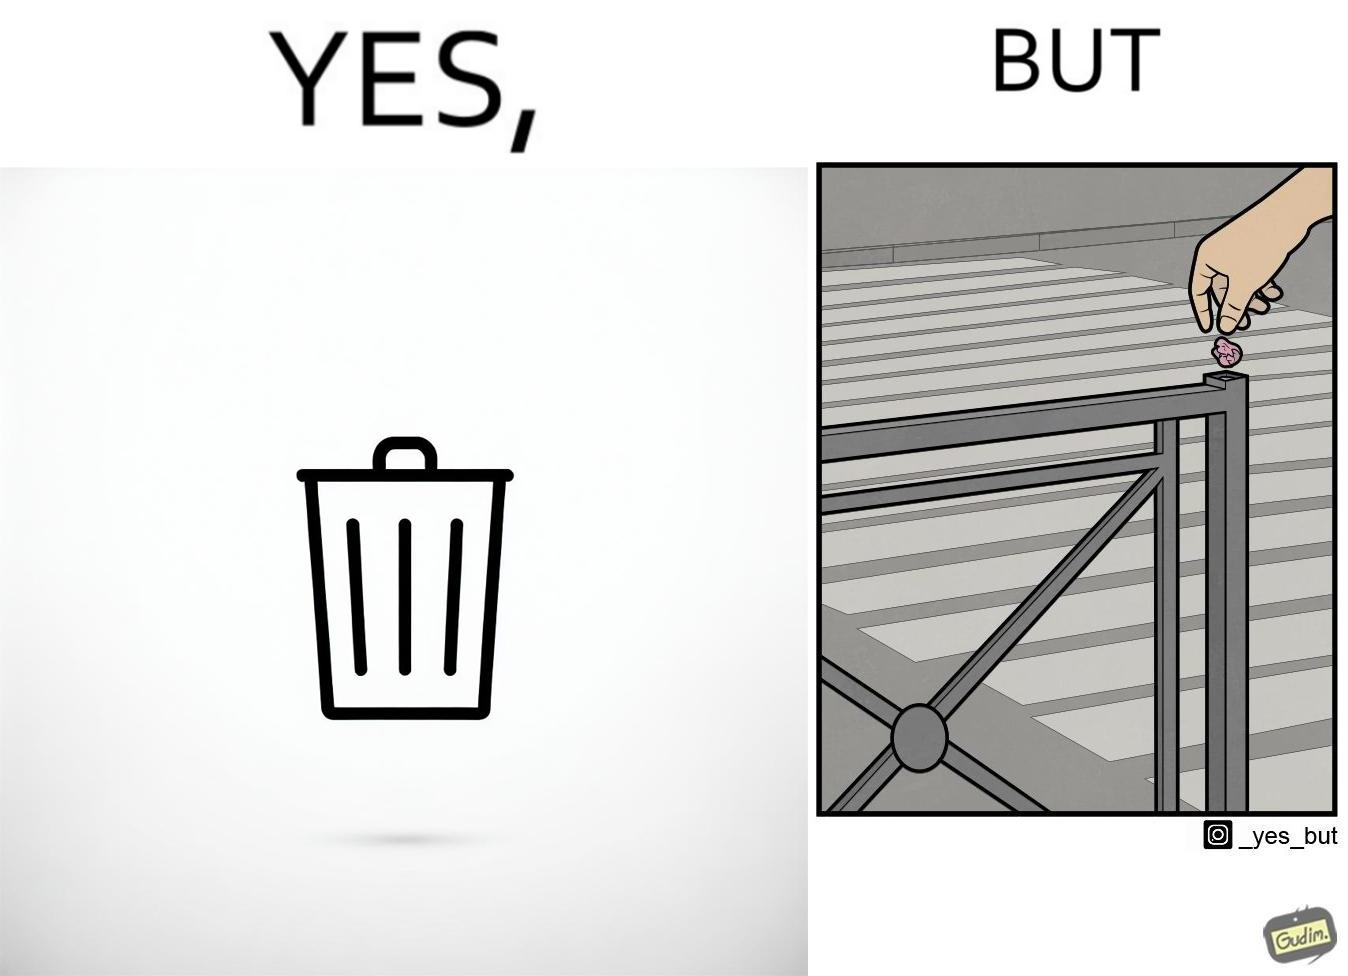What does this image depict? The images are ironic because even though garbage bins are provided for humans to dispose waste, by habit humans still choose to make surroundings dirty by disposing garbage improperly 